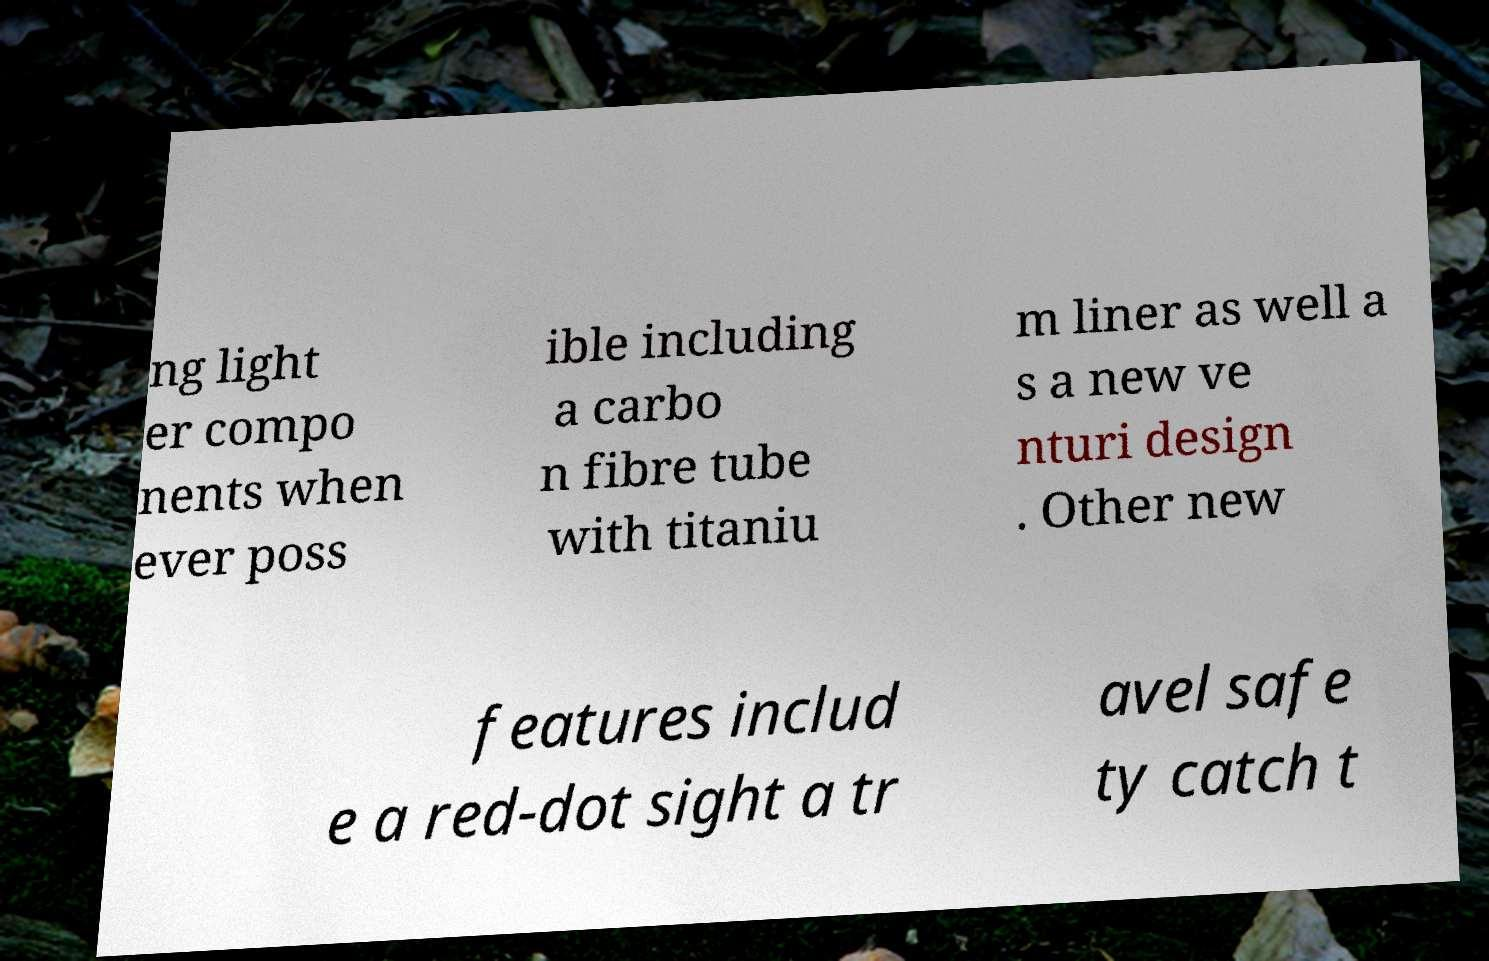For documentation purposes, I need the text within this image transcribed. Could you provide that? ng light er compo nents when ever poss ible including a carbo n fibre tube with titaniu m liner as well a s a new ve nturi design . Other new features includ e a red-dot sight a tr avel safe ty catch t 